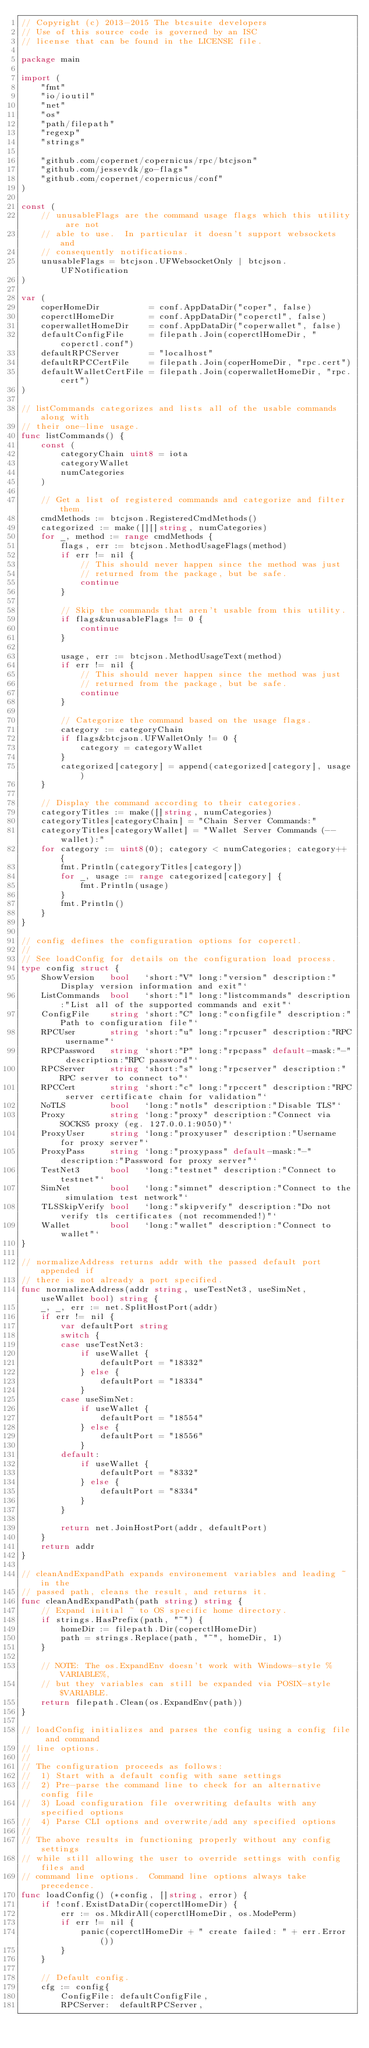Convert code to text. <code><loc_0><loc_0><loc_500><loc_500><_Go_>// Copyright (c) 2013-2015 The btcsuite developers
// Use of this source code is governed by an ISC
// license that can be found in the LICENSE file.

package main

import (
	"fmt"
	"io/ioutil"
	"net"
	"os"
	"path/filepath"
	"regexp"
	"strings"

	"github.com/copernet/copernicus/rpc/btcjson"
	"github.com/jessevdk/go-flags"
	"github.com/copernet/copernicus/conf"
)

const (
	// unusableFlags are the command usage flags which this utility are not
	// able to use.  In particular it doesn't support websockets and
	// consequently notifications.
	unusableFlags = btcjson.UFWebsocketOnly | btcjson.UFNotification
)

var (
	coperHomeDir          = conf.AppDataDir("coper", false)
	coperctlHomeDir       = conf.AppDataDir("coperctl", false)
	coperwalletHomeDir    = conf.AppDataDir("coperwallet", false)
	defaultConfigFile     = filepath.Join(coperctlHomeDir, "coperctl.conf")
	defaultRPCServer      = "localhost"
	defaultRPCCertFile    = filepath.Join(coperHomeDir, "rpc.cert")
	defaultWalletCertFile = filepath.Join(coperwalletHomeDir, "rpc.cert")
)

// listCommands categorizes and lists all of the usable commands along with
// their one-line usage.
func listCommands() {
	const (
		categoryChain uint8 = iota
		categoryWallet
		numCategories
	)

	// Get a list of registered commands and categorize and filter them.
	cmdMethods := btcjson.RegisteredCmdMethods()
	categorized := make([][]string, numCategories)
	for _, method := range cmdMethods {
		flags, err := btcjson.MethodUsageFlags(method)
		if err != nil {
			// This should never happen since the method was just
			// returned from the package, but be safe.
			continue
		}

		// Skip the commands that aren't usable from this utility.
		if flags&unusableFlags != 0 {
			continue
		}

		usage, err := btcjson.MethodUsageText(method)
		if err != nil {
			// This should never happen since the method was just
			// returned from the package, but be safe.
			continue
		}

		// Categorize the command based on the usage flags.
		category := categoryChain
		if flags&btcjson.UFWalletOnly != 0 {
			category = categoryWallet
		}
		categorized[category] = append(categorized[category], usage)
	}

	// Display the command according to their categories.
	categoryTitles := make([]string, numCategories)
	categoryTitles[categoryChain] = "Chain Server Commands:"
	categoryTitles[categoryWallet] = "Wallet Server Commands (--wallet):"
	for category := uint8(0); category < numCategories; category++ {
		fmt.Println(categoryTitles[category])
		for _, usage := range categorized[category] {
			fmt.Println(usage)
		}
		fmt.Println()
	}
}

// config defines the configuration options for coperctl.
//
// See loadConfig for details on the configuration load process.
type config struct {
	ShowVersion   bool   `short:"V" long:"version" description:"Display version information and exit"`
	ListCommands  bool   `short:"l" long:"listcommands" description:"List all of the supported commands and exit"`
	ConfigFile    string `short:"C" long:"configfile" description:"Path to configuration file"`
	RPCUser       string `short:"u" long:"rpcuser" description:"RPC username"`
	RPCPassword   string `short:"P" long:"rpcpass" default-mask:"-" description:"RPC password"`
	RPCServer     string `short:"s" long:"rpcserver" description:"RPC server to connect to"`
	RPCCert       string `short:"c" long:"rpccert" description:"RPC server certificate chain for validation"`
	NoTLS         bool   `long:"notls" description:"Disable TLS"`
	Proxy         string `long:"proxy" description:"Connect via SOCKS5 proxy (eg. 127.0.0.1:9050)"`
	ProxyUser     string `long:"proxyuser" description:"Username for proxy server"`
	ProxyPass     string `long:"proxypass" default-mask:"-" description:"Password for proxy server"`
	TestNet3      bool   `long:"testnet" description:"Connect to testnet"`
	SimNet        bool   `long:"simnet" description:"Connect to the simulation test network"`
	TLSSkipVerify bool   `long:"skipverify" description:"Do not verify tls certificates (not recommended!)"`
	Wallet        bool   `long:"wallet" description:"Connect to wallet"`
}

// normalizeAddress returns addr with the passed default port appended if
// there is not already a port specified.
func normalizeAddress(addr string, useTestNet3, useSimNet, useWallet bool) string {
	_, _, err := net.SplitHostPort(addr)
	if err != nil {
		var defaultPort string
		switch {
		case useTestNet3:
			if useWallet {
				defaultPort = "18332"
			} else {
				defaultPort = "18334"
			}
		case useSimNet:
			if useWallet {
				defaultPort = "18554"
			} else {
				defaultPort = "18556"
			}
		default:
			if useWallet {
				defaultPort = "8332"
			} else {
				defaultPort = "8334"
			}
		}

		return net.JoinHostPort(addr, defaultPort)
	}
	return addr
}

// cleanAndExpandPath expands environement variables and leading ~ in the
// passed path, cleans the result, and returns it.
func cleanAndExpandPath(path string) string {
	// Expand initial ~ to OS specific home directory.
	if strings.HasPrefix(path, "~") {
		homeDir := filepath.Dir(coperctlHomeDir)
		path = strings.Replace(path, "~", homeDir, 1)
	}

	// NOTE: The os.ExpandEnv doesn't work with Windows-style %VARIABLE%,
	// but they variables can still be expanded via POSIX-style $VARIABLE.
	return filepath.Clean(os.ExpandEnv(path))
}

// loadConfig initializes and parses the config using a config file and command
// line options.
//
// The configuration proceeds as follows:
// 	1) Start with a default config with sane settings
// 	2) Pre-parse the command line to check for an alternative config file
// 	3) Load configuration file overwriting defaults with any specified options
// 	4) Parse CLI options and overwrite/add any specified options
//
// The above results in functioning properly without any config settings
// while still allowing the user to override settings with config files and
// command line options.  Command line options always take precedence.
func loadConfig() (*config, []string, error) {
	if !conf.ExistDataDir(coperctlHomeDir) {
		err := os.MkdirAll(coperctlHomeDir, os.ModePerm)
		if err != nil {
			panic(coperctlHomeDir + " create failed: " + err.Error())
		}
	}

	// Default config.
	cfg := config{
		ConfigFile: defaultConfigFile,
		RPCServer:  defaultRPCServer,</code> 